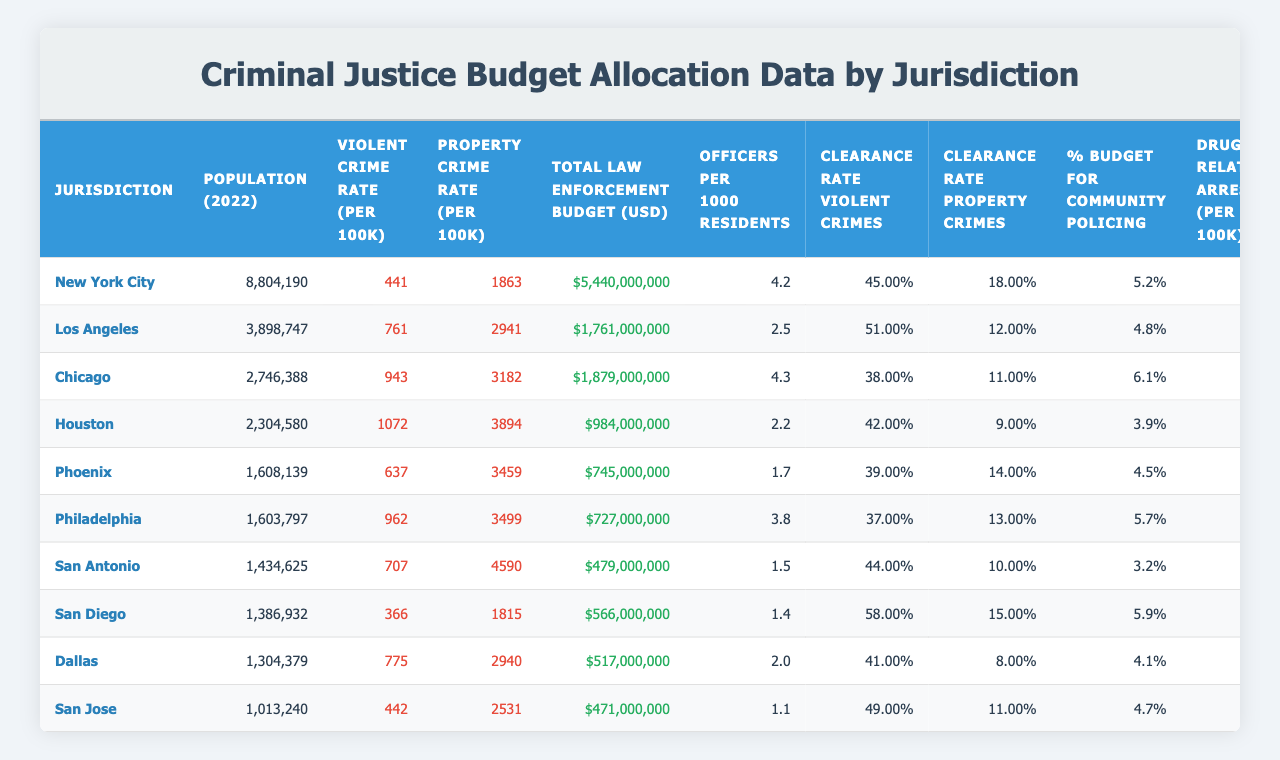What is the population of Los Angeles in 2022? According to the table, the population of Los Angeles in 2022 is given as 3,898,747.
Answer: 3,898,747 Which jurisdiction has the highest violent crime rate per 100k people? Looking at the table, Chicago has the highest violent crime rate at 943 per 100k.
Answer: Chicago What is the total law enforcement budget for New York City in 2022? The table states that New York City's total law enforcement budget for 2022 is $5,440,000,000.
Answer: $5,440,000,000 What is the clearance rate for property crimes in Chicago? The table indicates that Chicago's clearance rate for property crimes is 11%.
Answer: 11% What is the difference in officers per 1000 residents between San Antonio and Phoenix? San Antonio has 1.5 officers per 1000 residents and Phoenix has 1.7, so the difference is 1.7 - 1.5 = 0.2.
Answer: 0.2 Is the clearance rate for violent crimes in Philadelphia higher than that in Houston? The table shows that Philadelphia's clearance rate for violent crimes is 37% and Houston's is 42%. Since 37% is less than 42%, the statement is false.
Answer: No Which jurisdiction has both the highest property crime rate per 100k and the lowest violent crime rate per 100k? By comparing the tables, we find that San Antonio has the highest property crime rate at 4,590 per 100k, while San Diego has the lowest violent crime rate at 366 per 100k. So, no single jurisdiction fits both criteria.
Answer: None What is the average drug-related arrests per 100k for the jurisdictions listed? To find the average, sum all drug-related arrests per 100k values (239 + 312 + 418 + 376 + 287 + 401 + 294 + 198 + 352 + 217 = 2898) and divide by the number of jurisdictions (10). Thus, 2898 / 10 = 289.8.
Answer: 289.8 Are there more total law enforcement expenditures in jurisdictions with a violent crime rate above 700 per 100k than those below? Adding up the budgets, jurisdictions with a violent crime rate above 700 (Los Angeles, Chicago, Houston, Philadelphia, Dallas) have a total budget of $6,738,000,000, while those below (New York City, Phoenix, San Antonio, San Diego, San Jose) total $8,667,000,000. Since 8,667,000,000 is greater, the answer is yes.
Answer: Yes What proportion of the budget for law enforcement in San Diego is allocated for community policing? The table indicates that San Diego allocates 5.9% of its law enforcement budget for community policing, out of the total budget of $566,000,000.
Answer: 5.9% 